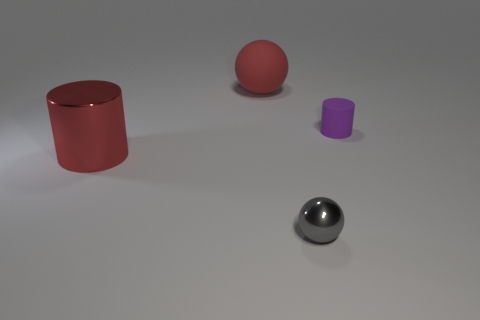Add 1 tiny cyan matte blocks. How many objects exist? 5 Subtract all purple cylinders. How many cylinders are left? 1 Subtract all green cylinders. Subtract all green balls. How many cylinders are left? 2 Subtract all cylinders. Subtract all large rubber spheres. How many objects are left? 1 Add 4 small purple things. How many small purple things are left? 5 Add 3 small matte cylinders. How many small matte cylinders exist? 4 Subtract 0 brown cylinders. How many objects are left? 4 